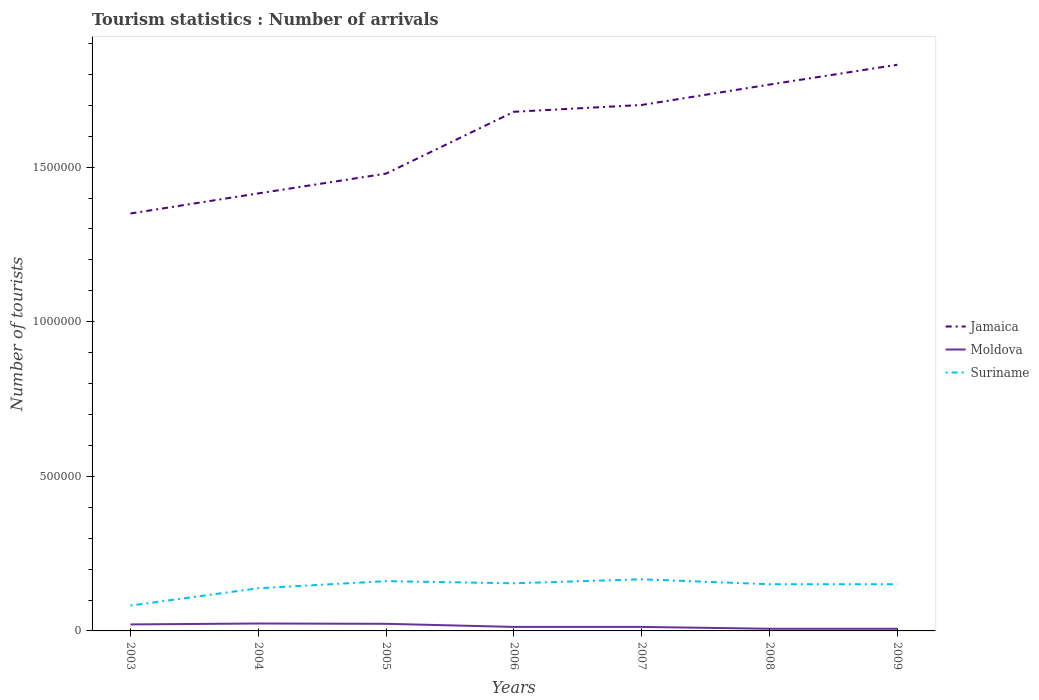Across all years, what is the maximum number of tourist arrivals in Suriname?
Your response must be concise. 8.20e+04. In which year was the number of tourist arrivals in Jamaica maximum?
Offer a very short reply. 2003. What is the total number of tourist arrivals in Jamaica in the graph?
Make the answer very short. -2.22e+05. What is the difference between the highest and the second highest number of tourist arrivals in Jamaica?
Your answer should be compact. 4.81e+05. Is the number of tourist arrivals in Moldova strictly greater than the number of tourist arrivals in Suriname over the years?
Give a very brief answer. Yes. How many lines are there?
Your answer should be compact. 3. Are the values on the major ticks of Y-axis written in scientific E-notation?
Ensure brevity in your answer.  No. How many legend labels are there?
Your answer should be very brief. 3. How are the legend labels stacked?
Offer a very short reply. Vertical. What is the title of the graph?
Offer a terse response. Tourism statistics : Number of arrivals. What is the label or title of the Y-axis?
Provide a short and direct response. Number of tourists. What is the Number of tourists of Jamaica in 2003?
Your answer should be compact. 1.35e+06. What is the Number of tourists in Moldova in 2003?
Provide a short and direct response. 2.10e+04. What is the Number of tourists in Suriname in 2003?
Give a very brief answer. 8.20e+04. What is the Number of tourists in Jamaica in 2004?
Ensure brevity in your answer.  1.42e+06. What is the Number of tourists in Moldova in 2004?
Provide a short and direct response. 2.40e+04. What is the Number of tourists in Suriname in 2004?
Your response must be concise. 1.38e+05. What is the Number of tourists in Jamaica in 2005?
Keep it short and to the point. 1.48e+06. What is the Number of tourists of Moldova in 2005?
Ensure brevity in your answer.  2.30e+04. What is the Number of tourists in Suriname in 2005?
Provide a succinct answer. 1.61e+05. What is the Number of tourists of Jamaica in 2006?
Offer a terse response. 1.68e+06. What is the Number of tourists of Moldova in 2006?
Offer a terse response. 1.30e+04. What is the Number of tourists in Suriname in 2006?
Your answer should be compact. 1.54e+05. What is the Number of tourists of Jamaica in 2007?
Provide a short and direct response. 1.70e+06. What is the Number of tourists in Moldova in 2007?
Your answer should be very brief. 1.30e+04. What is the Number of tourists of Suriname in 2007?
Your response must be concise. 1.67e+05. What is the Number of tourists in Jamaica in 2008?
Give a very brief answer. 1.77e+06. What is the Number of tourists of Moldova in 2008?
Provide a succinct answer. 7000. What is the Number of tourists in Suriname in 2008?
Your response must be concise. 1.51e+05. What is the Number of tourists of Jamaica in 2009?
Provide a short and direct response. 1.83e+06. What is the Number of tourists of Moldova in 2009?
Keep it short and to the point. 7000. What is the Number of tourists in Suriname in 2009?
Your answer should be very brief. 1.51e+05. Across all years, what is the maximum Number of tourists of Jamaica?
Your answer should be very brief. 1.83e+06. Across all years, what is the maximum Number of tourists in Moldova?
Your answer should be compact. 2.40e+04. Across all years, what is the maximum Number of tourists in Suriname?
Your response must be concise. 1.67e+05. Across all years, what is the minimum Number of tourists in Jamaica?
Your answer should be compact. 1.35e+06. Across all years, what is the minimum Number of tourists of Moldova?
Your response must be concise. 7000. Across all years, what is the minimum Number of tourists of Suriname?
Your answer should be compact. 8.20e+04. What is the total Number of tourists in Jamaica in the graph?
Offer a terse response. 1.12e+07. What is the total Number of tourists of Moldova in the graph?
Your answer should be compact. 1.08e+05. What is the total Number of tourists of Suriname in the graph?
Your response must be concise. 1.00e+06. What is the difference between the Number of tourists in Jamaica in 2003 and that in 2004?
Your answer should be compact. -6.50e+04. What is the difference between the Number of tourists in Moldova in 2003 and that in 2004?
Provide a short and direct response. -3000. What is the difference between the Number of tourists in Suriname in 2003 and that in 2004?
Ensure brevity in your answer.  -5.60e+04. What is the difference between the Number of tourists in Jamaica in 2003 and that in 2005?
Give a very brief answer. -1.29e+05. What is the difference between the Number of tourists of Moldova in 2003 and that in 2005?
Your answer should be compact. -2000. What is the difference between the Number of tourists in Suriname in 2003 and that in 2005?
Give a very brief answer. -7.90e+04. What is the difference between the Number of tourists of Jamaica in 2003 and that in 2006?
Keep it short and to the point. -3.29e+05. What is the difference between the Number of tourists of Moldova in 2003 and that in 2006?
Give a very brief answer. 8000. What is the difference between the Number of tourists of Suriname in 2003 and that in 2006?
Your response must be concise. -7.20e+04. What is the difference between the Number of tourists in Jamaica in 2003 and that in 2007?
Make the answer very short. -3.51e+05. What is the difference between the Number of tourists in Moldova in 2003 and that in 2007?
Offer a terse response. 8000. What is the difference between the Number of tourists in Suriname in 2003 and that in 2007?
Your answer should be very brief. -8.50e+04. What is the difference between the Number of tourists of Jamaica in 2003 and that in 2008?
Your response must be concise. -4.17e+05. What is the difference between the Number of tourists of Moldova in 2003 and that in 2008?
Keep it short and to the point. 1.40e+04. What is the difference between the Number of tourists in Suriname in 2003 and that in 2008?
Your answer should be compact. -6.90e+04. What is the difference between the Number of tourists in Jamaica in 2003 and that in 2009?
Provide a short and direct response. -4.81e+05. What is the difference between the Number of tourists of Moldova in 2003 and that in 2009?
Make the answer very short. 1.40e+04. What is the difference between the Number of tourists of Suriname in 2003 and that in 2009?
Give a very brief answer. -6.90e+04. What is the difference between the Number of tourists of Jamaica in 2004 and that in 2005?
Keep it short and to the point. -6.40e+04. What is the difference between the Number of tourists in Suriname in 2004 and that in 2005?
Make the answer very short. -2.30e+04. What is the difference between the Number of tourists in Jamaica in 2004 and that in 2006?
Give a very brief answer. -2.64e+05. What is the difference between the Number of tourists of Moldova in 2004 and that in 2006?
Make the answer very short. 1.10e+04. What is the difference between the Number of tourists in Suriname in 2004 and that in 2006?
Make the answer very short. -1.60e+04. What is the difference between the Number of tourists in Jamaica in 2004 and that in 2007?
Provide a short and direct response. -2.86e+05. What is the difference between the Number of tourists of Moldova in 2004 and that in 2007?
Provide a short and direct response. 1.10e+04. What is the difference between the Number of tourists of Suriname in 2004 and that in 2007?
Offer a terse response. -2.90e+04. What is the difference between the Number of tourists of Jamaica in 2004 and that in 2008?
Your answer should be very brief. -3.52e+05. What is the difference between the Number of tourists of Moldova in 2004 and that in 2008?
Make the answer very short. 1.70e+04. What is the difference between the Number of tourists of Suriname in 2004 and that in 2008?
Your answer should be compact. -1.30e+04. What is the difference between the Number of tourists of Jamaica in 2004 and that in 2009?
Ensure brevity in your answer.  -4.16e+05. What is the difference between the Number of tourists in Moldova in 2004 and that in 2009?
Offer a very short reply. 1.70e+04. What is the difference between the Number of tourists in Suriname in 2004 and that in 2009?
Offer a very short reply. -1.30e+04. What is the difference between the Number of tourists of Jamaica in 2005 and that in 2006?
Keep it short and to the point. -2.00e+05. What is the difference between the Number of tourists in Moldova in 2005 and that in 2006?
Make the answer very short. 10000. What is the difference between the Number of tourists of Suriname in 2005 and that in 2006?
Your answer should be very brief. 7000. What is the difference between the Number of tourists in Jamaica in 2005 and that in 2007?
Ensure brevity in your answer.  -2.22e+05. What is the difference between the Number of tourists of Suriname in 2005 and that in 2007?
Your response must be concise. -6000. What is the difference between the Number of tourists in Jamaica in 2005 and that in 2008?
Your response must be concise. -2.88e+05. What is the difference between the Number of tourists in Moldova in 2005 and that in 2008?
Your answer should be compact. 1.60e+04. What is the difference between the Number of tourists of Suriname in 2005 and that in 2008?
Offer a terse response. 10000. What is the difference between the Number of tourists of Jamaica in 2005 and that in 2009?
Your answer should be compact. -3.52e+05. What is the difference between the Number of tourists in Moldova in 2005 and that in 2009?
Offer a very short reply. 1.60e+04. What is the difference between the Number of tourists of Suriname in 2005 and that in 2009?
Your answer should be compact. 10000. What is the difference between the Number of tourists in Jamaica in 2006 and that in 2007?
Keep it short and to the point. -2.20e+04. What is the difference between the Number of tourists of Moldova in 2006 and that in 2007?
Keep it short and to the point. 0. What is the difference between the Number of tourists of Suriname in 2006 and that in 2007?
Provide a succinct answer. -1.30e+04. What is the difference between the Number of tourists in Jamaica in 2006 and that in 2008?
Offer a very short reply. -8.80e+04. What is the difference between the Number of tourists in Moldova in 2006 and that in 2008?
Give a very brief answer. 6000. What is the difference between the Number of tourists in Suriname in 2006 and that in 2008?
Your answer should be compact. 3000. What is the difference between the Number of tourists of Jamaica in 2006 and that in 2009?
Provide a short and direct response. -1.52e+05. What is the difference between the Number of tourists in Moldova in 2006 and that in 2009?
Give a very brief answer. 6000. What is the difference between the Number of tourists in Suriname in 2006 and that in 2009?
Offer a terse response. 3000. What is the difference between the Number of tourists in Jamaica in 2007 and that in 2008?
Your answer should be very brief. -6.60e+04. What is the difference between the Number of tourists of Moldova in 2007 and that in 2008?
Provide a short and direct response. 6000. What is the difference between the Number of tourists in Suriname in 2007 and that in 2008?
Give a very brief answer. 1.60e+04. What is the difference between the Number of tourists of Moldova in 2007 and that in 2009?
Make the answer very short. 6000. What is the difference between the Number of tourists of Suriname in 2007 and that in 2009?
Your answer should be compact. 1.60e+04. What is the difference between the Number of tourists in Jamaica in 2008 and that in 2009?
Provide a succinct answer. -6.40e+04. What is the difference between the Number of tourists of Suriname in 2008 and that in 2009?
Your answer should be compact. 0. What is the difference between the Number of tourists in Jamaica in 2003 and the Number of tourists in Moldova in 2004?
Your answer should be compact. 1.33e+06. What is the difference between the Number of tourists in Jamaica in 2003 and the Number of tourists in Suriname in 2004?
Make the answer very short. 1.21e+06. What is the difference between the Number of tourists in Moldova in 2003 and the Number of tourists in Suriname in 2004?
Keep it short and to the point. -1.17e+05. What is the difference between the Number of tourists in Jamaica in 2003 and the Number of tourists in Moldova in 2005?
Make the answer very short. 1.33e+06. What is the difference between the Number of tourists of Jamaica in 2003 and the Number of tourists of Suriname in 2005?
Provide a succinct answer. 1.19e+06. What is the difference between the Number of tourists in Jamaica in 2003 and the Number of tourists in Moldova in 2006?
Your response must be concise. 1.34e+06. What is the difference between the Number of tourists of Jamaica in 2003 and the Number of tourists of Suriname in 2006?
Provide a short and direct response. 1.20e+06. What is the difference between the Number of tourists of Moldova in 2003 and the Number of tourists of Suriname in 2006?
Provide a short and direct response. -1.33e+05. What is the difference between the Number of tourists in Jamaica in 2003 and the Number of tourists in Moldova in 2007?
Give a very brief answer. 1.34e+06. What is the difference between the Number of tourists of Jamaica in 2003 and the Number of tourists of Suriname in 2007?
Your answer should be compact. 1.18e+06. What is the difference between the Number of tourists in Moldova in 2003 and the Number of tourists in Suriname in 2007?
Provide a succinct answer. -1.46e+05. What is the difference between the Number of tourists of Jamaica in 2003 and the Number of tourists of Moldova in 2008?
Make the answer very short. 1.34e+06. What is the difference between the Number of tourists of Jamaica in 2003 and the Number of tourists of Suriname in 2008?
Offer a terse response. 1.20e+06. What is the difference between the Number of tourists of Moldova in 2003 and the Number of tourists of Suriname in 2008?
Offer a very short reply. -1.30e+05. What is the difference between the Number of tourists in Jamaica in 2003 and the Number of tourists in Moldova in 2009?
Make the answer very short. 1.34e+06. What is the difference between the Number of tourists in Jamaica in 2003 and the Number of tourists in Suriname in 2009?
Keep it short and to the point. 1.20e+06. What is the difference between the Number of tourists in Jamaica in 2004 and the Number of tourists in Moldova in 2005?
Make the answer very short. 1.39e+06. What is the difference between the Number of tourists of Jamaica in 2004 and the Number of tourists of Suriname in 2005?
Your response must be concise. 1.25e+06. What is the difference between the Number of tourists of Moldova in 2004 and the Number of tourists of Suriname in 2005?
Your answer should be very brief. -1.37e+05. What is the difference between the Number of tourists of Jamaica in 2004 and the Number of tourists of Moldova in 2006?
Provide a succinct answer. 1.40e+06. What is the difference between the Number of tourists in Jamaica in 2004 and the Number of tourists in Suriname in 2006?
Your response must be concise. 1.26e+06. What is the difference between the Number of tourists in Jamaica in 2004 and the Number of tourists in Moldova in 2007?
Your answer should be very brief. 1.40e+06. What is the difference between the Number of tourists of Jamaica in 2004 and the Number of tourists of Suriname in 2007?
Make the answer very short. 1.25e+06. What is the difference between the Number of tourists in Moldova in 2004 and the Number of tourists in Suriname in 2007?
Your answer should be compact. -1.43e+05. What is the difference between the Number of tourists of Jamaica in 2004 and the Number of tourists of Moldova in 2008?
Provide a succinct answer. 1.41e+06. What is the difference between the Number of tourists of Jamaica in 2004 and the Number of tourists of Suriname in 2008?
Make the answer very short. 1.26e+06. What is the difference between the Number of tourists of Moldova in 2004 and the Number of tourists of Suriname in 2008?
Your answer should be compact. -1.27e+05. What is the difference between the Number of tourists in Jamaica in 2004 and the Number of tourists in Moldova in 2009?
Ensure brevity in your answer.  1.41e+06. What is the difference between the Number of tourists in Jamaica in 2004 and the Number of tourists in Suriname in 2009?
Your answer should be very brief. 1.26e+06. What is the difference between the Number of tourists in Moldova in 2004 and the Number of tourists in Suriname in 2009?
Your response must be concise. -1.27e+05. What is the difference between the Number of tourists of Jamaica in 2005 and the Number of tourists of Moldova in 2006?
Make the answer very short. 1.47e+06. What is the difference between the Number of tourists in Jamaica in 2005 and the Number of tourists in Suriname in 2006?
Your response must be concise. 1.32e+06. What is the difference between the Number of tourists in Moldova in 2005 and the Number of tourists in Suriname in 2006?
Offer a terse response. -1.31e+05. What is the difference between the Number of tourists in Jamaica in 2005 and the Number of tourists in Moldova in 2007?
Ensure brevity in your answer.  1.47e+06. What is the difference between the Number of tourists of Jamaica in 2005 and the Number of tourists of Suriname in 2007?
Provide a short and direct response. 1.31e+06. What is the difference between the Number of tourists in Moldova in 2005 and the Number of tourists in Suriname in 2007?
Make the answer very short. -1.44e+05. What is the difference between the Number of tourists of Jamaica in 2005 and the Number of tourists of Moldova in 2008?
Ensure brevity in your answer.  1.47e+06. What is the difference between the Number of tourists of Jamaica in 2005 and the Number of tourists of Suriname in 2008?
Your answer should be compact. 1.33e+06. What is the difference between the Number of tourists in Moldova in 2005 and the Number of tourists in Suriname in 2008?
Your answer should be very brief. -1.28e+05. What is the difference between the Number of tourists in Jamaica in 2005 and the Number of tourists in Moldova in 2009?
Provide a succinct answer. 1.47e+06. What is the difference between the Number of tourists of Jamaica in 2005 and the Number of tourists of Suriname in 2009?
Provide a succinct answer. 1.33e+06. What is the difference between the Number of tourists in Moldova in 2005 and the Number of tourists in Suriname in 2009?
Offer a terse response. -1.28e+05. What is the difference between the Number of tourists in Jamaica in 2006 and the Number of tourists in Moldova in 2007?
Provide a succinct answer. 1.67e+06. What is the difference between the Number of tourists in Jamaica in 2006 and the Number of tourists in Suriname in 2007?
Keep it short and to the point. 1.51e+06. What is the difference between the Number of tourists in Moldova in 2006 and the Number of tourists in Suriname in 2007?
Your answer should be compact. -1.54e+05. What is the difference between the Number of tourists in Jamaica in 2006 and the Number of tourists in Moldova in 2008?
Give a very brief answer. 1.67e+06. What is the difference between the Number of tourists of Jamaica in 2006 and the Number of tourists of Suriname in 2008?
Ensure brevity in your answer.  1.53e+06. What is the difference between the Number of tourists of Moldova in 2006 and the Number of tourists of Suriname in 2008?
Give a very brief answer. -1.38e+05. What is the difference between the Number of tourists in Jamaica in 2006 and the Number of tourists in Moldova in 2009?
Your response must be concise. 1.67e+06. What is the difference between the Number of tourists of Jamaica in 2006 and the Number of tourists of Suriname in 2009?
Keep it short and to the point. 1.53e+06. What is the difference between the Number of tourists of Moldova in 2006 and the Number of tourists of Suriname in 2009?
Offer a terse response. -1.38e+05. What is the difference between the Number of tourists in Jamaica in 2007 and the Number of tourists in Moldova in 2008?
Your answer should be compact. 1.69e+06. What is the difference between the Number of tourists in Jamaica in 2007 and the Number of tourists in Suriname in 2008?
Offer a terse response. 1.55e+06. What is the difference between the Number of tourists in Moldova in 2007 and the Number of tourists in Suriname in 2008?
Your answer should be very brief. -1.38e+05. What is the difference between the Number of tourists of Jamaica in 2007 and the Number of tourists of Moldova in 2009?
Provide a succinct answer. 1.69e+06. What is the difference between the Number of tourists in Jamaica in 2007 and the Number of tourists in Suriname in 2009?
Your answer should be compact. 1.55e+06. What is the difference between the Number of tourists of Moldova in 2007 and the Number of tourists of Suriname in 2009?
Provide a short and direct response. -1.38e+05. What is the difference between the Number of tourists of Jamaica in 2008 and the Number of tourists of Moldova in 2009?
Give a very brief answer. 1.76e+06. What is the difference between the Number of tourists of Jamaica in 2008 and the Number of tourists of Suriname in 2009?
Ensure brevity in your answer.  1.62e+06. What is the difference between the Number of tourists of Moldova in 2008 and the Number of tourists of Suriname in 2009?
Provide a short and direct response. -1.44e+05. What is the average Number of tourists in Jamaica per year?
Provide a short and direct response. 1.60e+06. What is the average Number of tourists of Moldova per year?
Offer a very short reply. 1.54e+04. What is the average Number of tourists in Suriname per year?
Keep it short and to the point. 1.43e+05. In the year 2003, what is the difference between the Number of tourists of Jamaica and Number of tourists of Moldova?
Offer a very short reply. 1.33e+06. In the year 2003, what is the difference between the Number of tourists in Jamaica and Number of tourists in Suriname?
Keep it short and to the point. 1.27e+06. In the year 2003, what is the difference between the Number of tourists of Moldova and Number of tourists of Suriname?
Ensure brevity in your answer.  -6.10e+04. In the year 2004, what is the difference between the Number of tourists in Jamaica and Number of tourists in Moldova?
Provide a short and direct response. 1.39e+06. In the year 2004, what is the difference between the Number of tourists of Jamaica and Number of tourists of Suriname?
Your response must be concise. 1.28e+06. In the year 2004, what is the difference between the Number of tourists in Moldova and Number of tourists in Suriname?
Keep it short and to the point. -1.14e+05. In the year 2005, what is the difference between the Number of tourists in Jamaica and Number of tourists in Moldova?
Make the answer very short. 1.46e+06. In the year 2005, what is the difference between the Number of tourists of Jamaica and Number of tourists of Suriname?
Provide a short and direct response. 1.32e+06. In the year 2005, what is the difference between the Number of tourists in Moldova and Number of tourists in Suriname?
Your response must be concise. -1.38e+05. In the year 2006, what is the difference between the Number of tourists in Jamaica and Number of tourists in Moldova?
Make the answer very short. 1.67e+06. In the year 2006, what is the difference between the Number of tourists of Jamaica and Number of tourists of Suriname?
Give a very brief answer. 1.52e+06. In the year 2006, what is the difference between the Number of tourists in Moldova and Number of tourists in Suriname?
Make the answer very short. -1.41e+05. In the year 2007, what is the difference between the Number of tourists of Jamaica and Number of tourists of Moldova?
Your response must be concise. 1.69e+06. In the year 2007, what is the difference between the Number of tourists of Jamaica and Number of tourists of Suriname?
Your response must be concise. 1.53e+06. In the year 2007, what is the difference between the Number of tourists in Moldova and Number of tourists in Suriname?
Ensure brevity in your answer.  -1.54e+05. In the year 2008, what is the difference between the Number of tourists of Jamaica and Number of tourists of Moldova?
Make the answer very short. 1.76e+06. In the year 2008, what is the difference between the Number of tourists in Jamaica and Number of tourists in Suriname?
Offer a terse response. 1.62e+06. In the year 2008, what is the difference between the Number of tourists in Moldova and Number of tourists in Suriname?
Offer a terse response. -1.44e+05. In the year 2009, what is the difference between the Number of tourists of Jamaica and Number of tourists of Moldova?
Your answer should be very brief. 1.82e+06. In the year 2009, what is the difference between the Number of tourists in Jamaica and Number of tourists in Suriname?
Provide a short and direct response. 1.68e+06. In the year 2009, what is the difference between the Number of tourists in Moldova and Number of tourists in Suriname?
Keep it short and to the point. -1.44e+05. What is the ratio of the Number of tourists in Jamaica in 2003 to that in 2004?
Your response must be concise. 0.95. What is the ratio of the Number of tourists in Suriname in 2003 to that in 2004?
Offer a terse response. 0.59. What is the ratio of the Number of tourists of Jamaica in 2003 to that in 2005?
Keep it short and to the point. 0.91. What is the ratio of the Number of tourists in Moldova in 2003 to that in 2005?
Give a very brief answer. 0.91. What is the ratio of the Number of tourists of Suriname in 2003 to that in 2005?
Ensure brevity in your answer.  0.51. What is the ratio of the Number of tourists in Jamaica in 2003 to that in 2006?
Your response must be concise. 0.8. What is the ratio of the Number of tourists of Moldova in 2003 to that in 2006?
Ensure brevity in your answer.  1.62. What is the ratio of the Number of tourists of Suriname in 2003 to that in 2006?
Your answer should be compact. 0.53. What is the ratio of the Number of tourists of Jamaica in 2003 to that in 2007?
Your answer should be compact. 0.79. What is the ratio of the Number of tourists in Moldova in 2003 to that in 2007?
Your response must be concise. 1.62. What is the ratio of the Number of tourists in Suriname in 2003 to that in 2007?
Your answer should be compact. 0.49. What is the ratio of the Number of tourists in Jamaica in 2003 to that in 2008?
Offer a very short reply. 0.76. What is the ratio of the Number of tourists in Suriname in 2003 to that in 2008?
Provide a succinct answer. 0.54. What is the ratio of the Number of tourists of Jamaica in 2003 to that in 2009?
Give a very brief answer. 0.74. What is the ratio of the Number of tourists in Moldova in 2003 to that in 2009?
Ensure brevity in your answer.  3. What is the ratio of the Number of tourists in Suriname in 2003 to that in 2009?
Your answer should be compact. 0.54. What is the ratio of the Number of tourists of Jamaica in 2004 to that in 2005?
Your answer should be very brief. 0.96. What is the ratio of the Number of tourists in Moldova in 2004 to that in 2005?
Your answer should be compact. 1.04. What is the ratio of the Number of tourists of Jamaica in 2004 to that in 2006?
Offer a very short reply. 0.84. What is the ratio of the Number of tourists in Moldova in 2004 to that in 2006?
Offer a very short reply. 1.85. What is the ratio of the Number of tourists in Suriname in 2004 to that in 2006?
Offer a terse response. 0.9. What is the ratio of the Number of tourists in Jamaica in 2004 to that in 2007?
Provide a short and direct response. 0.83. What is the ratio of the Number of tourists of Moldova in 2004 to that in 2007?
Your response must be concise. 1.85. What is the ratio of the Number of tourists of Suriname in 2004 to that in 2007?
Provide a succinct answer. 0.83. What is the ratio of the Number of tourists of Jamaica in 2004 to that in 2008?
Your answer should be compact. 0.8. What is the ratio of the Number of tourists in Moldova in 2004 to that in 2008?
Provide a succinct answer. 3.43. What is the ratio of the Number of tourists of Suriname in 2004 to that in 2008?
Provide a succinct answer. 0.91. What is the ratio of the Number of tourists of Jamaica in 2004 to that in 2009?
Give a very brief answer. 0.77. What is the ratio of the Number of tourists in Moldova in 2004 to that in 2009?
Make the answer very short. 3.43. What is the ratio of the Number of tourists of Suriname in 2004 to that in 2009?
Your answer should be compact. 0.91. What is the ratio of the Number of tourists in Jamaica in 2005 to that in 2006?
Provide a short and direct response. 0.88. What is the ratio of the Number of tourists of Moldova in 2005 to that in 2006?
Offer a very short reply. 1.77. What is the ratio of the Number of tourists in Suriname in 2005 to that in 2006?
Provide a short and direct response. 1.05. What is the ratio of the Number of tourists of Jamaica in 2005 to that in 2007?
Ensure brevity in your answer.  0.87. What is the ratio of the Number of tourists in Moldova in 2005 to that in 2007?
Your answer should be very brief. 1.77. What is the ratio of the Number of tourists in Suriname in 2005 to that in 2007?
Provide a succinct answer. 0.96. What is the ratio of the Number of tourists in Jamaica in 2005 to that in 2008?
Provide a short and direct response. 0.84. What is the ratio of the Number of tourists in Moldova in 2005 to that in 2008?
Offer a very short reply. 3.29. What is the ratio of the Number of tourists of Suriname in 2005 to that in 2008?
Your response must be concise. 1.07. What is the ratio of the Number of tourists of Jamaica in 2005 to that in 2009?
Your answer should be very brief. 0.81. What is the ratio of the Number of tourists of Moldova in 2005 to that in 2009?
Your answer should be compact. 3.29. What is the ratio of the Number of tourists in Suriname in 2005 to that in 2009?
Keep it short and to the point. 1.07. What is the ratio of the Number of tourists in Jamaica in 2006 to that in 2007?
Your response must be concise. 0.99. What is the ratio of the Number of tourists of Suriname in 2006 to that in 2007?
Offer a very short reply. 0.92. What is the ratio of the Number of tourists in Jamaica in 2006 to that in 2008?
Give a very brief answer. 0.95. What is the ratio of the Number of tourists of Moldova in 2006 to that in 2008?
Offer a terse response. 1.86. What is the ratio of the Number of tourists of Suriname in 2006 to that in 2008?
Your answer should be very brief. 1.02. What is the ratio of the Number of tourists in Jamaica in 2006 to that in 2009?
Provide a short and direct response. 0.92. What is the ratio of the Number of tourists in Moldova in 2006 to that in 2009?
Make the answer very short. 1.86. What is the ratio of the Number of tourists in Suriname in 2006 to that in 2009?
Make the answer very short. 1.02. What is the ratio of the Number of tourists in Jamaica in 2007 to that in 2008?
Provide a succinct answer. 0.96. What is the ratio of the Number of tourists in Moldova in 2007 to that in 2008?
Give a very brief answer. 1.86. What is the ratio of the Number of tourists in Suriname in 2007 to that in 2008?
Offer a very short reply. 1.11. What is the ratio of the Number of tourists of Jamaica in 2007 to that in 2009?
Provide a short and direct response. 0.93. What is the ratio of the Number of tourists in Moldova in 2007 to that in 2009?
Your answer should be very brief. 1.86. What is the ratio of the Number of tourists of Suriname in 2007 to that in 2009?
Offer a very short reply. 1.11. What is the ratio of the Number of tourists in Jamaica in 2008 to that in 2009?
Your response must be concise. 0.96. What is the ratio of the Number of tourists in Moldova in 2008 to that in 2009?
Your response must be concise. 1. What is the ratio of the Number of tourists in Suriname in 2008 to that in 2009?
Provide a succinct answer. 1. What is the difference between the highest and the second highest Number of tourists of Jamaica?
Your response must be concise. 6.40e+04. What is the difference between the highest and the second highest Number of tourists of Moldova?
Give a very brief answer. 1000. What is the difference between the highest and the second highest Number of tourists in Suriname?
Keep it short and to the point. 6000. What is the difference between the highest and the lowest Number of tourists in Jamaica?
Give a very brief answer. 4.81e+05. What is the difference between the highest and the lowest Number of tourists in Moldova?
Offer a terse response. 1.70e+04. What is the difference between the highest and the lowest Number of tourists in Suriname?
Give a very brief answer. 8.50e+04. 